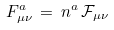Convert formula to latex. <formula><loc_0><loc_0><loc_500><loc_500>F _ { \mu \nu } ^ { a } \, = \, n ^ { a } \, \mathcal { F } _ { \mu \nu }</formula> 